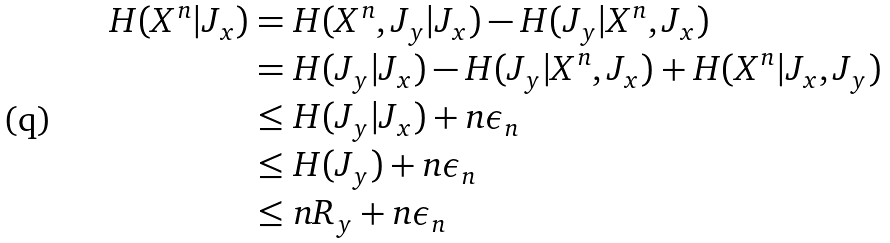Convert formula to latex. <formula><loc_0><loc_0><loc_500><loc_500>H ( X ^ { n } | J _ { x } ) & = H ( X ^ { n } , J _ { y } | J _ { x } ) - H ( J _ { y } | X ^ { n } , J _ { x } ) \\ & = H ( J _ { y } | J _ { x } ) - H ( J _ { y } | X ^ { n } , J _ { x } ) + H ( X ^ { n } | J _ { x } , J _ { y } ) \\ & \leq H ( J _ { y } | J _ { x } ) + n \epsilon _ { n } \\ & \leq H ( J _ { y } ) + n \epsilon _ { n } \\ & \leq n R _ { y } + n \epsilon _ { n }</formula> 